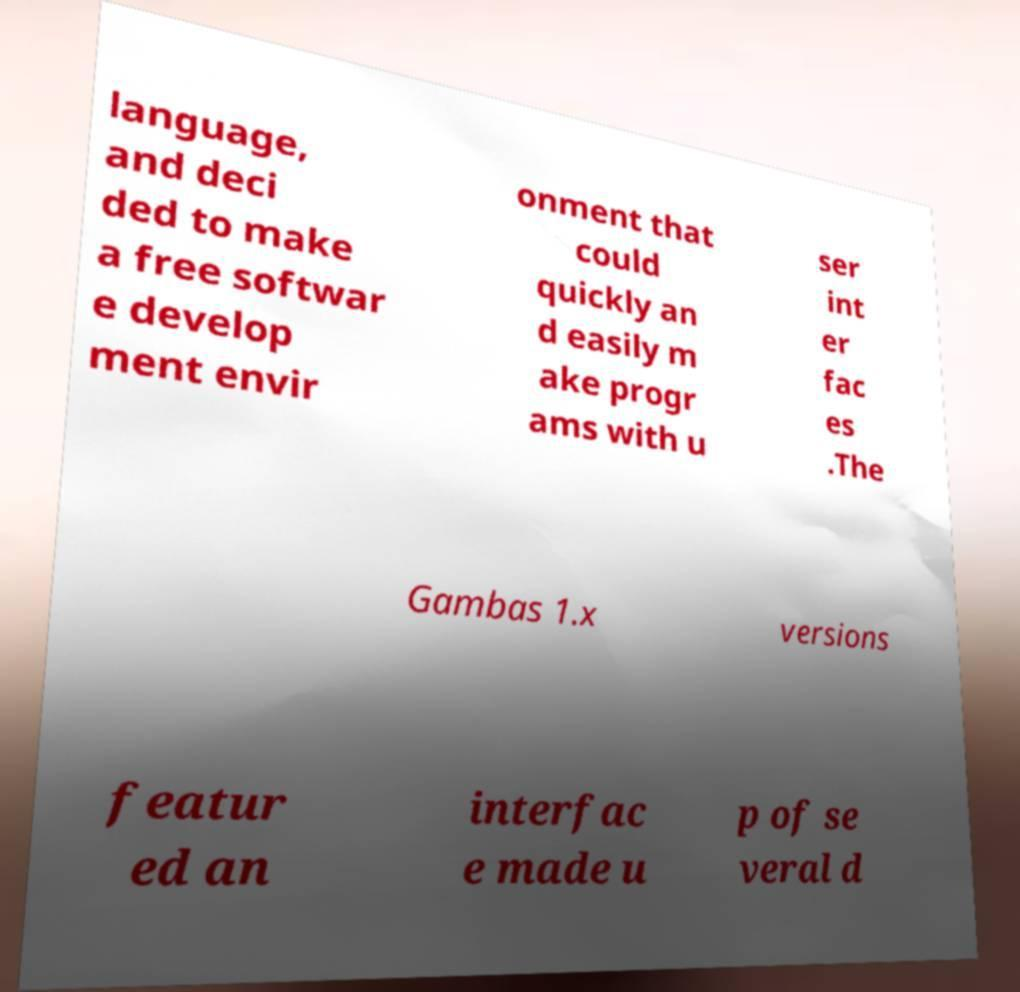What messages or text are displayed in this image? I need them in a readable, typed format. language, and deci ded to make a free softwar e develop ment envir onment that could quickly an d easily m ake progr ams with u ser int er fac es .The Gambas 1.x versions featur ed an interfac e made u p of se veral d 